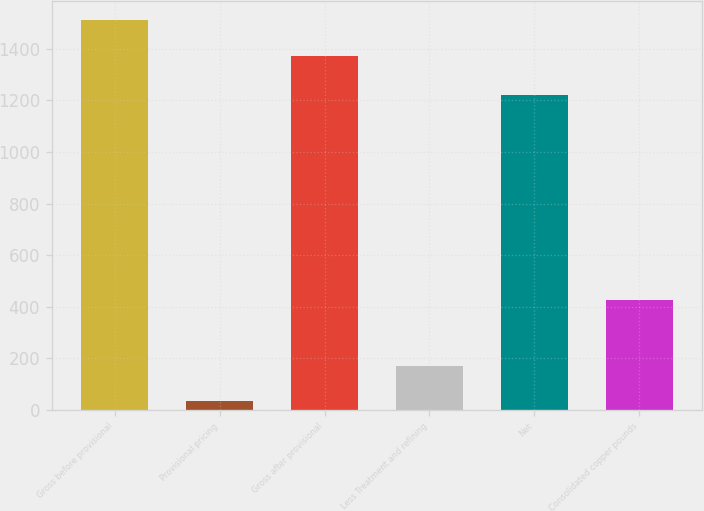Convert chart. <chart><loc_0><loc_0><loc_500><loc_500><bar_chart><fcel>Gross before provisional<fcel>Provisional pricing<fcel>Gross after provisional<fcel>Less Treatment and refining<fcel>Net<fcel>Consolidated copper pounds<nl><fcel>1511.5<fcel>34<fcel>1374<fcel>171.5<fcel>1221<fcel>428<nl></chart> 